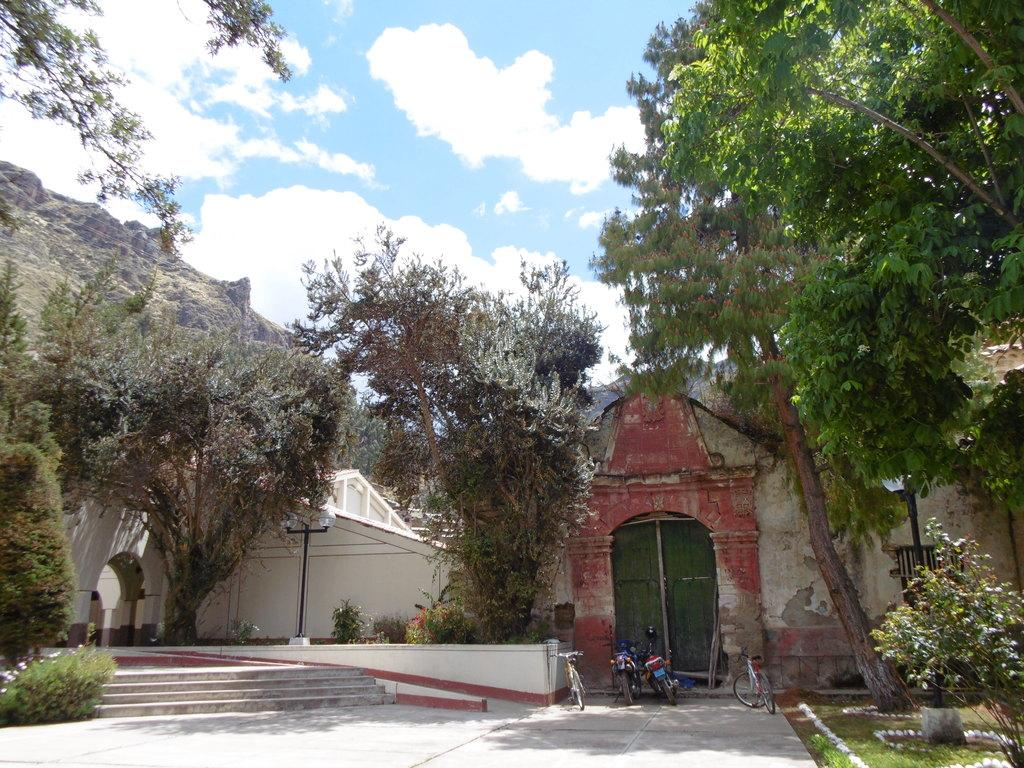What type of structure is present in the image? There is a building in the image. What colors are used on the building? The building has white and red colors. What else can be seen in the image besides the building? There are vehicles in the image. What is visible in the background of the image? There are trees in the background of the image. What color are the trees? The trees have green colors. What is visible at the top of the image? The sky is visible in the image. What colors are present in the sky? The sky has white and blue colors. What type of behavior can be observed in the time depicted in the image? There is no specific behavior being depicted in the image, as it is a static scene featuring a building, vehicles, trees, and the sky. 